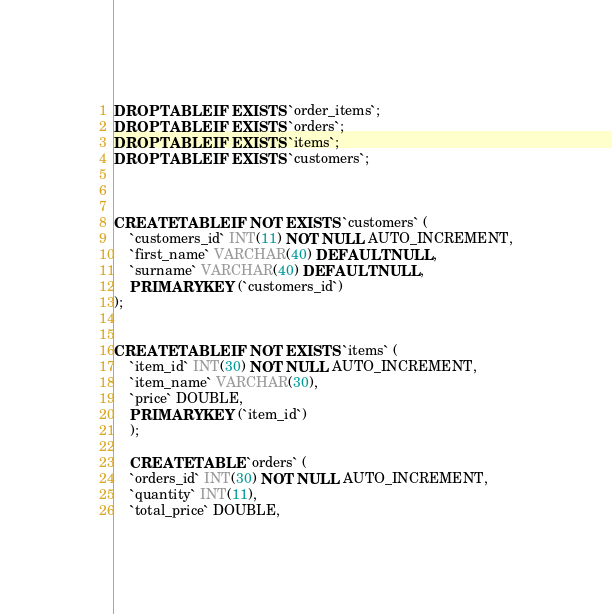Convert code to text. <code><loc_0><loc_0><loc_500><loc_500><_SQL_>DROP TABLE IF EXISTS `order_items`;
DROP TABLE IF EXISTS `orders`;
DROP TABLE IF EXISTS `items`;
DROP TABLE IF EXISTS `customers`;



CREATE TABLE IF NOT EXISTS `customers` (
    `customers_id` INT(11) NOT NULL AUTO_INCREMENT,
    `first_name` VARCHAR(40) DEFAULT NULL,
    `surname` VARCHAR(40) DEFAULT NULL,
    PRIMARY KEY (`customers_id`)
);


CREATE TABLE IF NOT EXISTS `items` (
    `item_id` INT(30) NOT NULL AUTO_INCREMENT,
    `item_name` VARCHAR(30),
    `price` DOUBLE,
    PRIMARY KEY (`item_id`)
    );
    
    CREATE TABLE `orders` (
    `orders_id` INT(30) NOT NULL AUTO_INCREMENT,
    `quantity` INT(11),
    `total_price` DOUBLE,</code> 